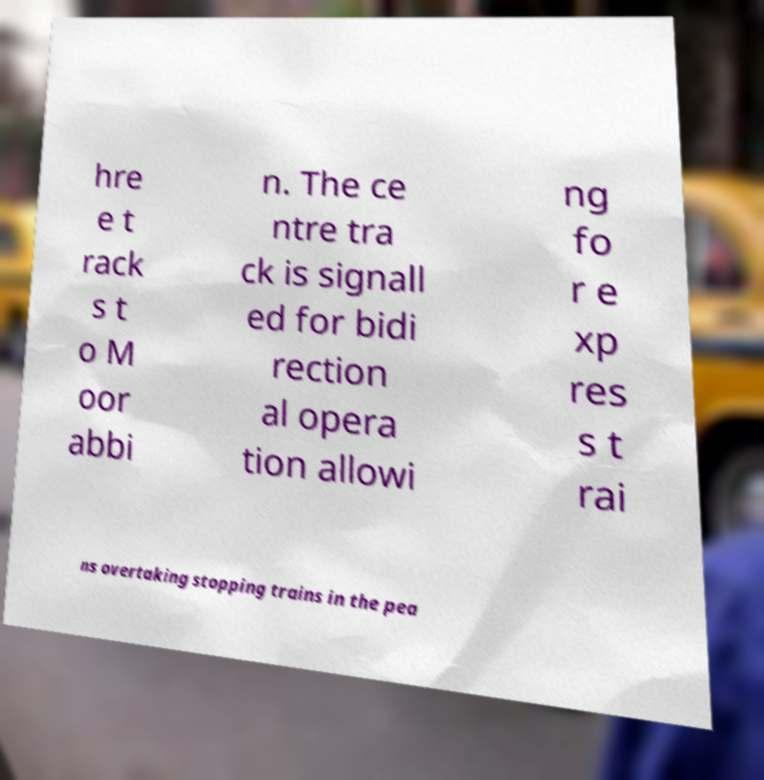There's text embedded in this image that I need extracted. Can you transcribe it verbatim? hre e t rack s t o M oor abbi n. The ce ntre tra ck is signall ed for bidi rection al opera tion allowi ng fo r e xp res s t rai ns overtaking stopping trains in the pea 